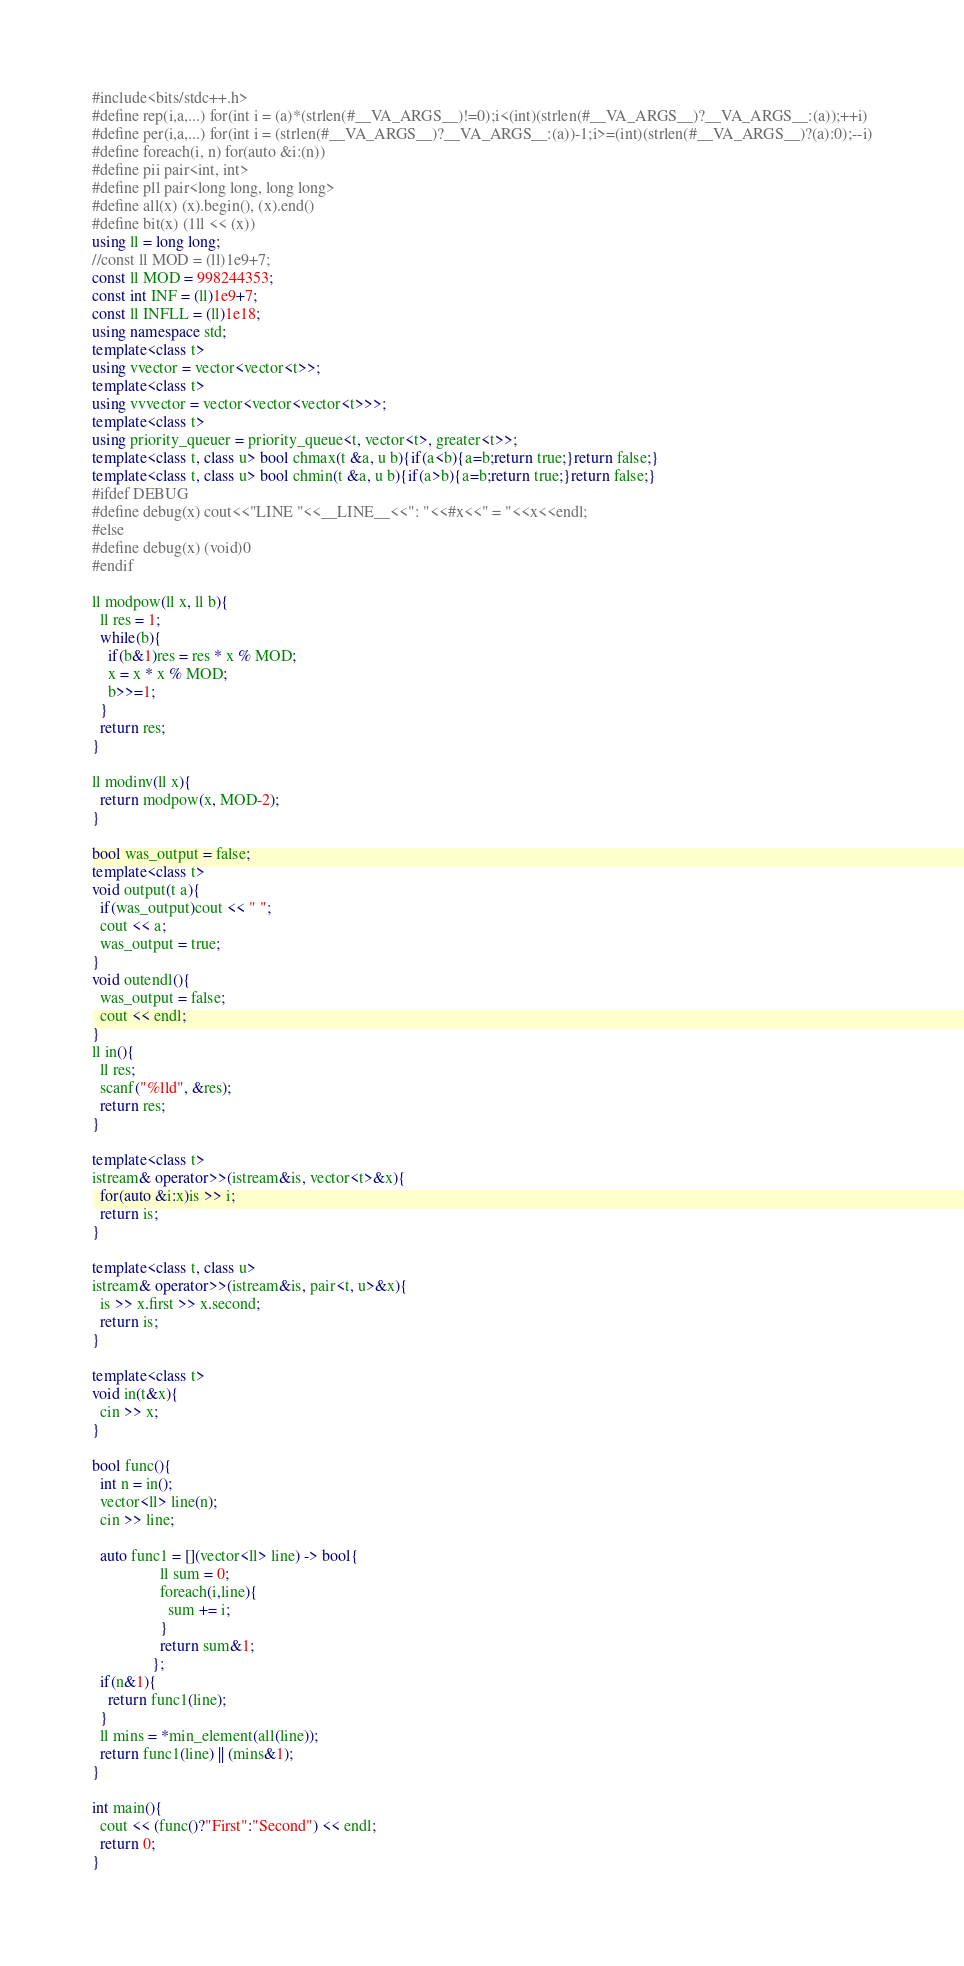<code> <loc_0><loc_0><loc_500><loc_500><_C++_>#include<bits/stdc++.h>
#define rep(i,a,...) for(int i = (a)*(strlen(#__VA_ARGS__)!=0);i<(int)(strlen(#__VA_ARGS__)?__VA_ARGS__:(a));++i)
#define per(i,a,...) for(int i = (strlen(#__VA_ARGS__)?__VA_ARGS__:(a))-1;i>=(int)(strlen(#__VA_ARGS__)?(a):0);--i)
#define foreach(i, n) for(auto &i:(n))
#define pii pair<int, int>
#define pll pair<long long, long long>
#define all(x) (x).begin(), (x).end()
#define bit(x) (1ll << (x))
using ll = long long;
//const ll MOD = (ll)1e9+7;
const ll MOD = 998244353;
const int INF = (ll)1e9+7;
const ll INFLL = (ll)1e18;
using namespace std;
template<class t>
using vvector = vector<vector<t>>;
template<class t>
using vvvector = vector<vector<vector<t>>>;
template<class t>
using priority_queuer = priority_queue<t, vector<t>, greater<t>>;
template<class t, class u> bool chmax(t &a, u b){if(a<b){a=b;return true;}return false;}
template<class t, class u> bool chmin(t &a, u b){if(a>b){a=b;return true;}return false;}
#ifdef DEBUG
#define debug(x) cout<<"LINE "<<__LINE__<<": "<<#x<<" = "<<x<<endl;
#else
#define debug(x) (void)0
#endif

ll modpow(ll x, ll b){
  ll res = 1;
  while(b){
    if(b&1)res = res * x % MOD;
    x = x * x % MOD;
    b>>=1;
  }
  return res;
}

ll modinv(ll x){
  return modpow(x, MOD-2);
}

bool was_output = false;
template<class t>
void output(t a){
  if(was_output)cout << " ";
  cout << a;
  was_output = true;
}
void outendl(){
  was_output = false;
  cout << endl;
}
ll in(){
  ll res;
  scanf("%lld", &res);
  return res;
}

template<class t>
istream& operator>>(istream&is, vector<t>&x){
  for(auto &i:x)is >> i;
  return is;
}

template<class t, class u>
istream& operator>>(istream&is, pair<t, u>&x){
  is >> x.first >> x.second;
  return is;
}

template<class t>
void in(t&x){
  cin >> x;
}

bool func(){
  int n = in();
  vector<ll> line(n);
  cin >> line;

  auto func1 = [](vector<ll> line) -> bool{
                 ll sum = 0;
                 foreach(i,line){
                   sum += i;
                 }
                 return sum&1;
               };
  if(n&1){
    return func1(line);
  }
  ll mins = *min_element(all(line));
  return func1(line) || (mins&1);
}

int main(){
  cout << (func()?"First":"Second") << endl;
  return 0;
}

</code> 